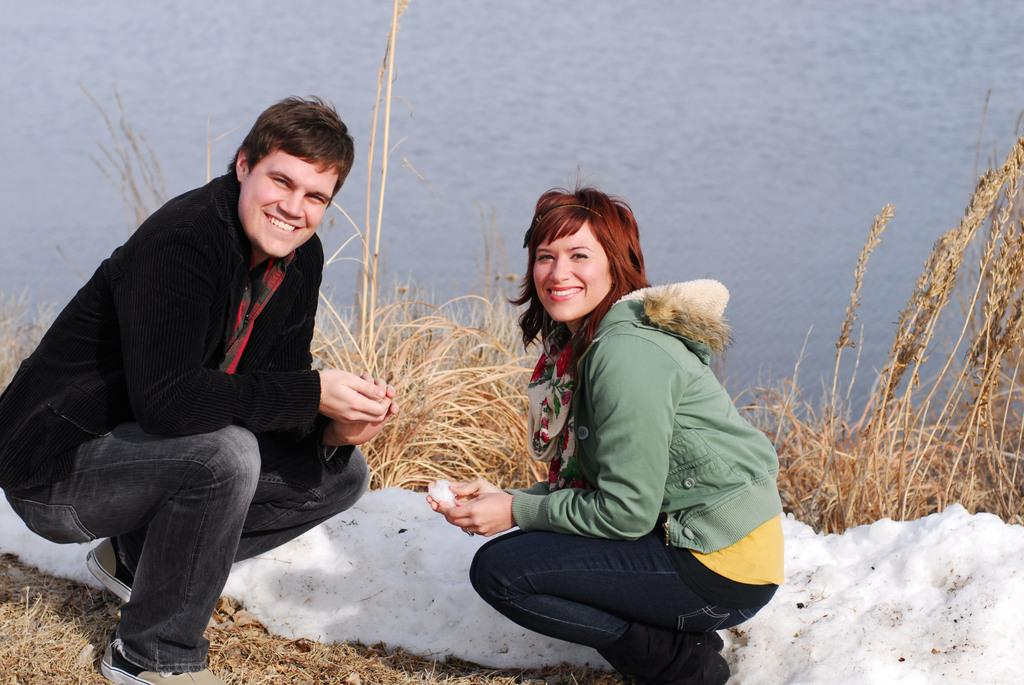How many people are in the image? There are two people in the image, a man and a woman. What are the man and woman wearing? Both the man and woman are wearing clothes and shoes. What is the facial expression of the man and woman? The man and woman are smiling in the image. What position are the man and woman in? They are sitting in the squad position. What is the weather or season like in the image? There is snow visible in the image, which suggests a cold or winter season. What type of vegetation is present in the image? Dry grass is present in the image. What else can be seen in the image besides the people and vegetation? There is water visible in the image. What invention is being demonstrated by the man and woman in the image? There is no invention being demonstrated in the image; it simply shows a man and woman sitting in the squad position. 